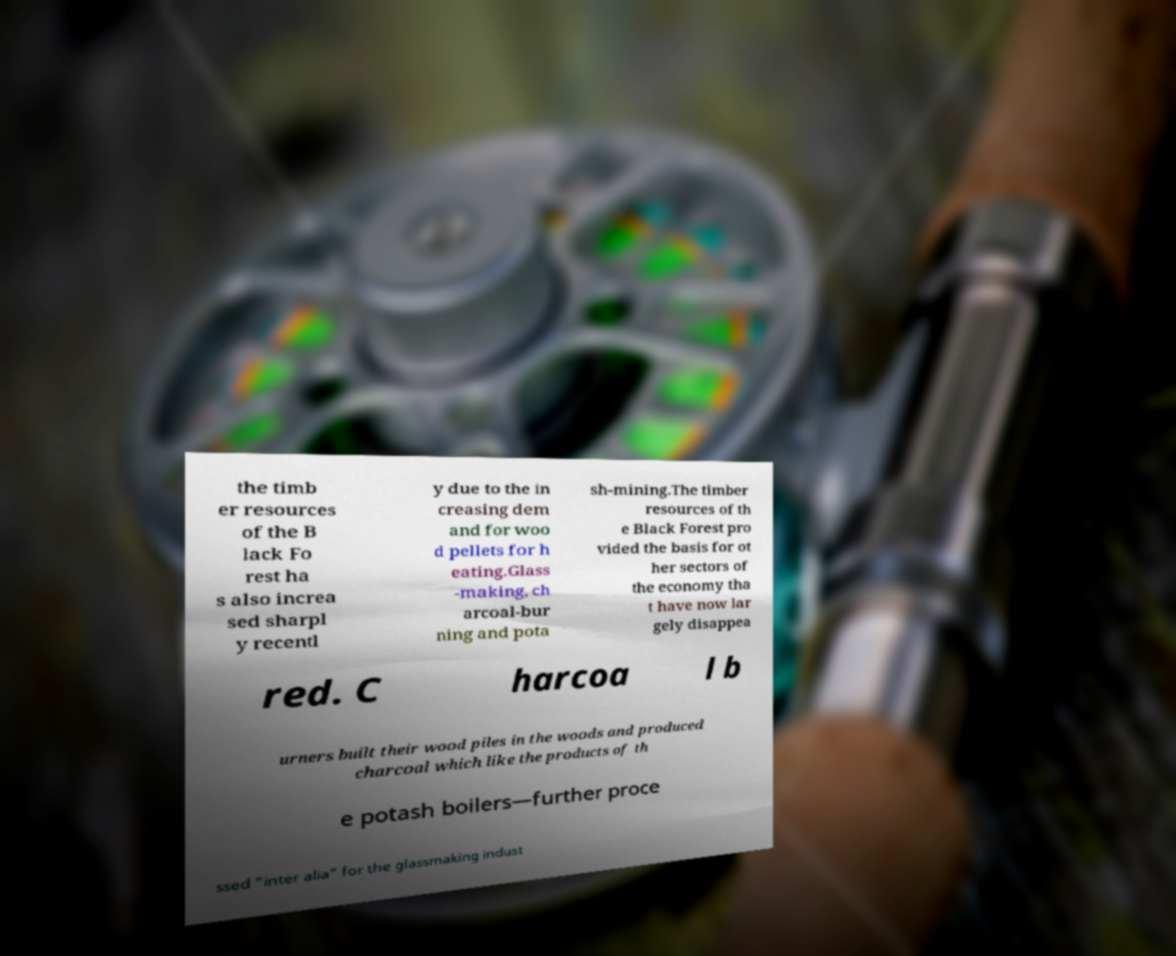Can you read and provide the text displayed in the image?This photo seems to have some interesting text. Can you extract and type it out for me? the timb er resources of the B lack Fo rest ha s also increa sed sharpl y recentl y due to the in creasing dem and for woo d pellets for h eating.Glass -making, ch arcoal-bur ning and pota sh-mining.The timber resources of th e Black Forest pro vided the basis for ot her sectors of the economy tha t have now lar gely disappea red. C harcoa l b urners built their wood piles in the woods and produced charcoal which like the products of th e potash boilers—further proce ssed "inter alia" for the glassmaking indust 